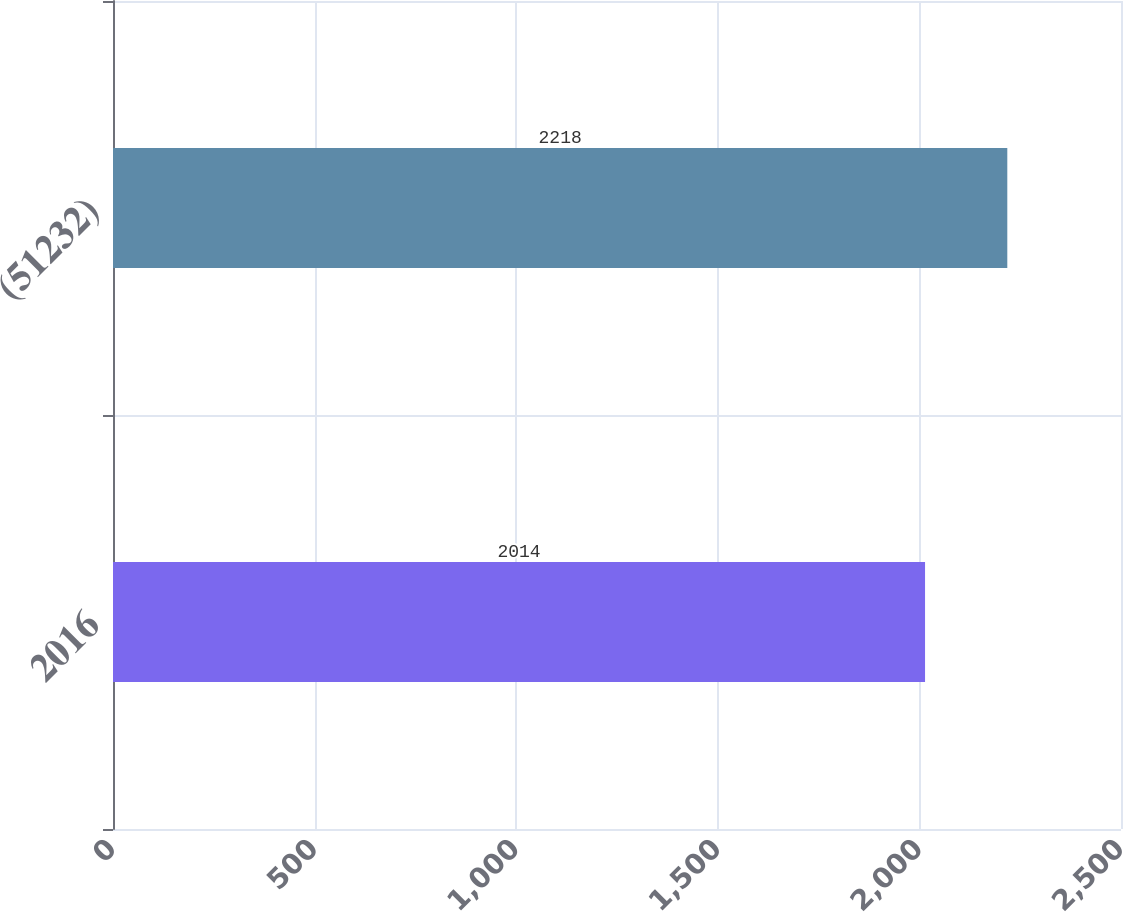Convert chart. <chart><loc_0><loc_0><loc_500><loc_500><bar_chart><fcel>2016<fcel>(51232)<nl><fcel>2014<fcel>2218<nl></chart> 